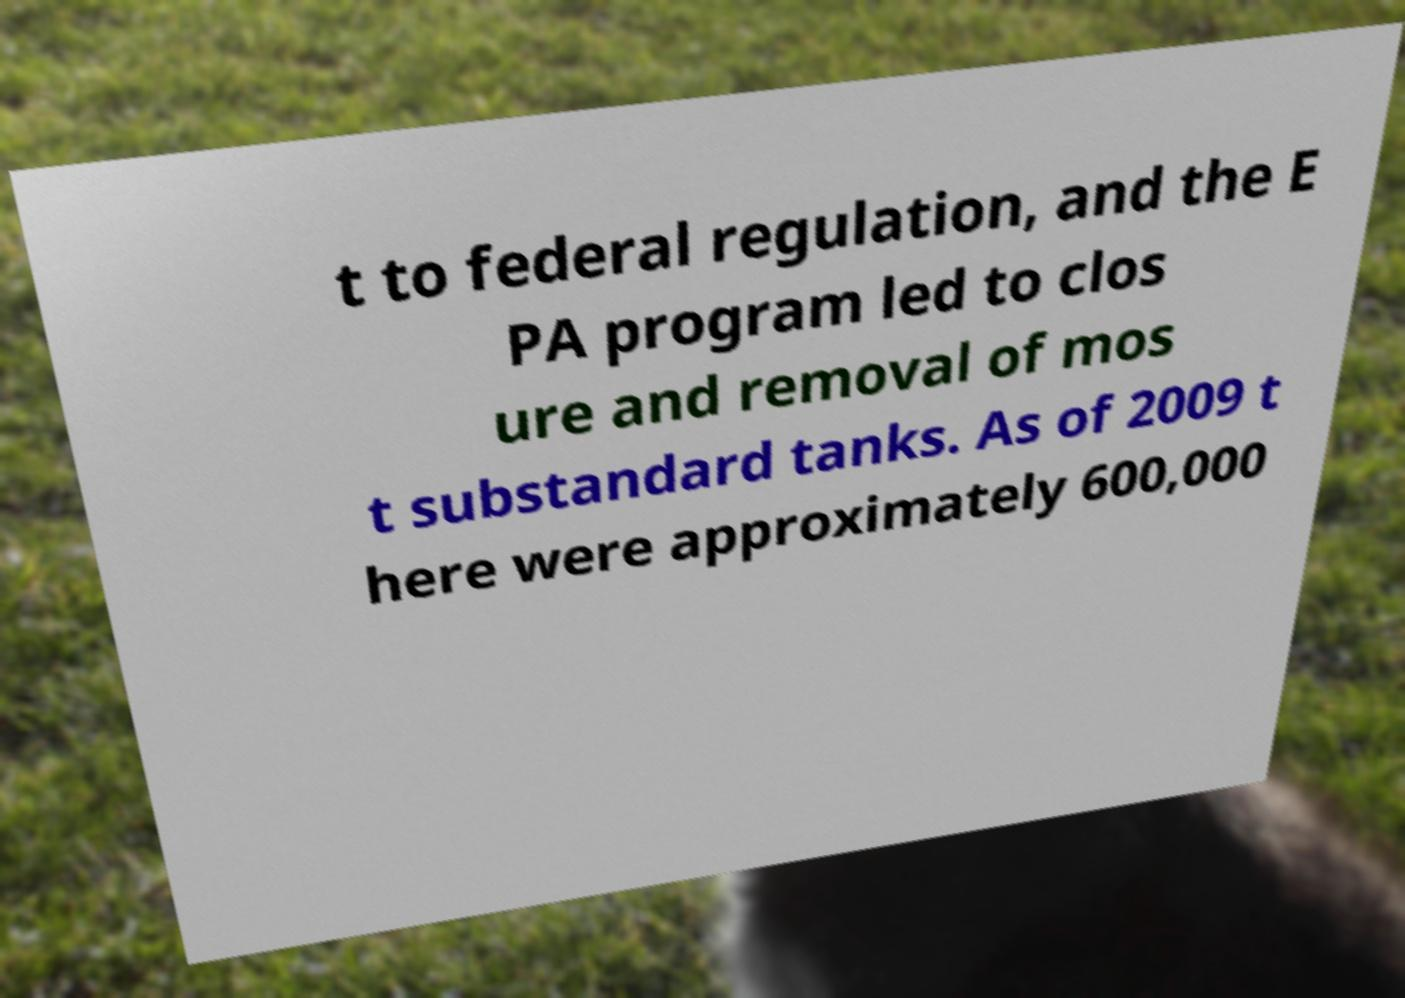Please read and relay the text visible in this image. What does it say? t to federal regulation, and the E PA program led to clos ure and removal of mos t substandard tanks. As of 2009 t here were approximately 600,000 